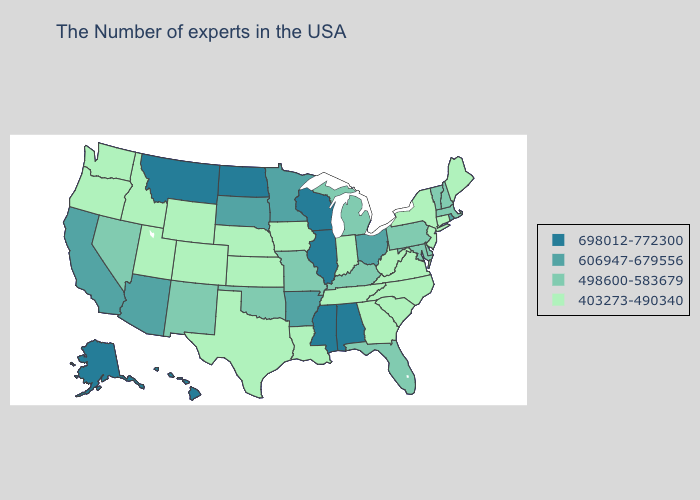Among the states that border Rhode Island , does Massachusetts have the highest value?
Write a very short answer. Yes. Which states have the highest value in the USA?
Write a very short answer. Alabama, Wisconsin, Illinois, Mississippi, North Dakota, Montana, Alaska, Hawaii. Does Minnesota have the same value as Missouri?
Short answer required. No. What is the lowest value in states that border New Hampshire?
Give a very brief answer. 403273-490340. Among the states that border Maine , which have the highest value?
Be succinct. New Hampshire. What is the value of North Dakota?
Write a very short answer. 698012-772300. Which states have the highest value in the USA?
Answer briefly. Alabama, Wisconsin, Illinois, Mississippi, North Dakota, Montana, Alaska, Hawaii. What is the lowest value in the USA?
Quick response, please. 403273-490340. Does the first symbol in the legend represent the smallest category?
Answer briefly. No. Does the map have missing data?
Give a very brief answer. No. What is the value of Utah?
Concise answer only. 403273-490340. Does Rhode Island have the highest value in the Northeast?
Write a very short answer. Yes. What is the lowest value in the USA?
Keep it brief. 403273-490340. What is the highest value in states that border Iowa?
Write a very short answer. 698012-772300. Which states have the highest value in the USA?
Concise answer only. Alabama, Wisconsin, Illinois, Mississippi, North Dakota, Montana, Alaska, Hawaii. 